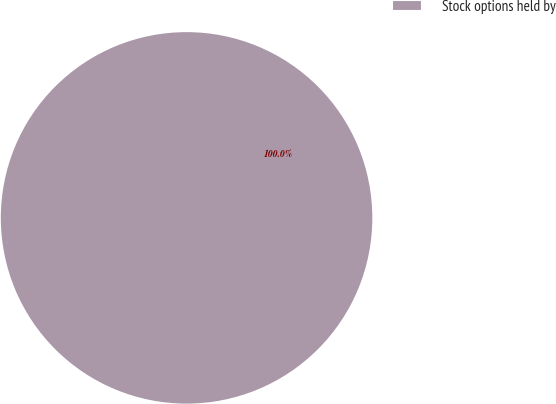Convert chart. <chart><loc_0><loc_0><loc_500><loc_500><pie_chart><fcel>Stock options held by<nl><fcel>100.0%<nl></chart> 